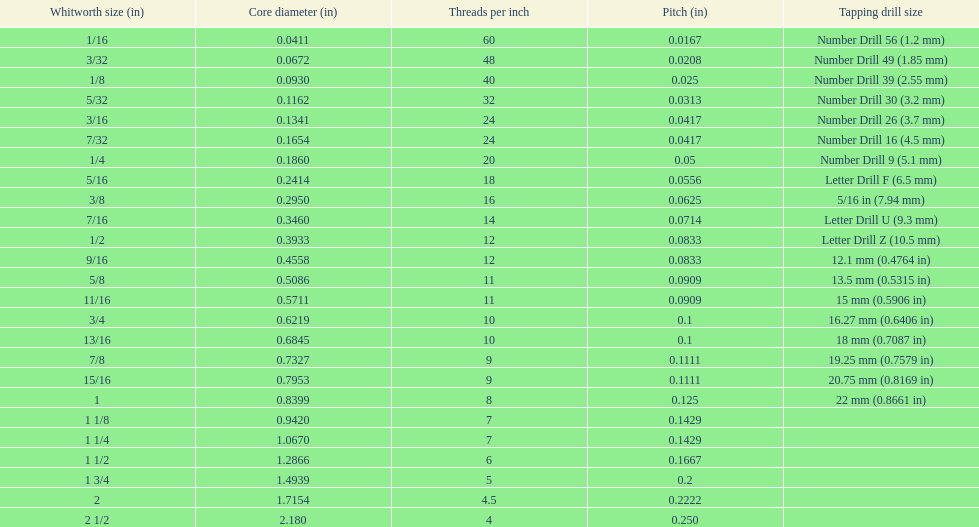What is the core diameter of the last whitworth thread size? 2.180. 